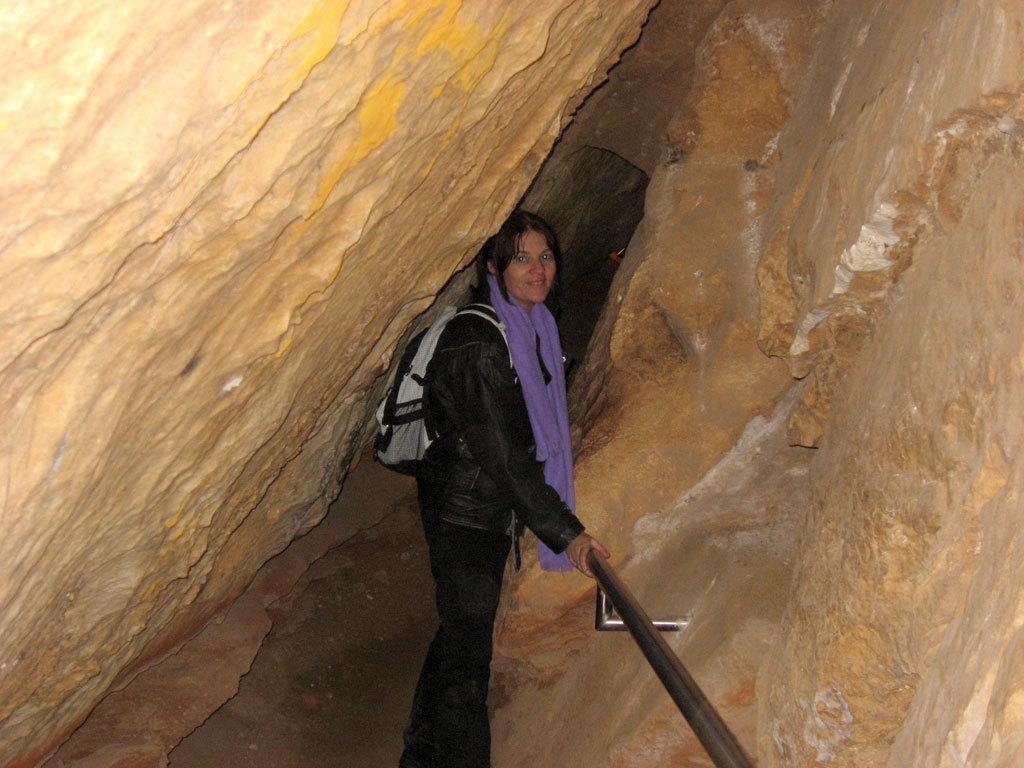What is the main setting of the image? The image depicts a cave. Is there anyone present in the cave? Yes, there is a woman standing inside the cave. What is the woman doing in the cave? The woman is holding a handrail. Where is the handrail located in the cave? The handrail is on the wall of the cave. What type of art can be seen hanging on the wall of the cave? There is no art visible on the wall of the cave in the image. Can you tell me how many scarecrows are present in the cave? There are no scarecrows present in the cave; only a woman holding a handrail can be seen. 